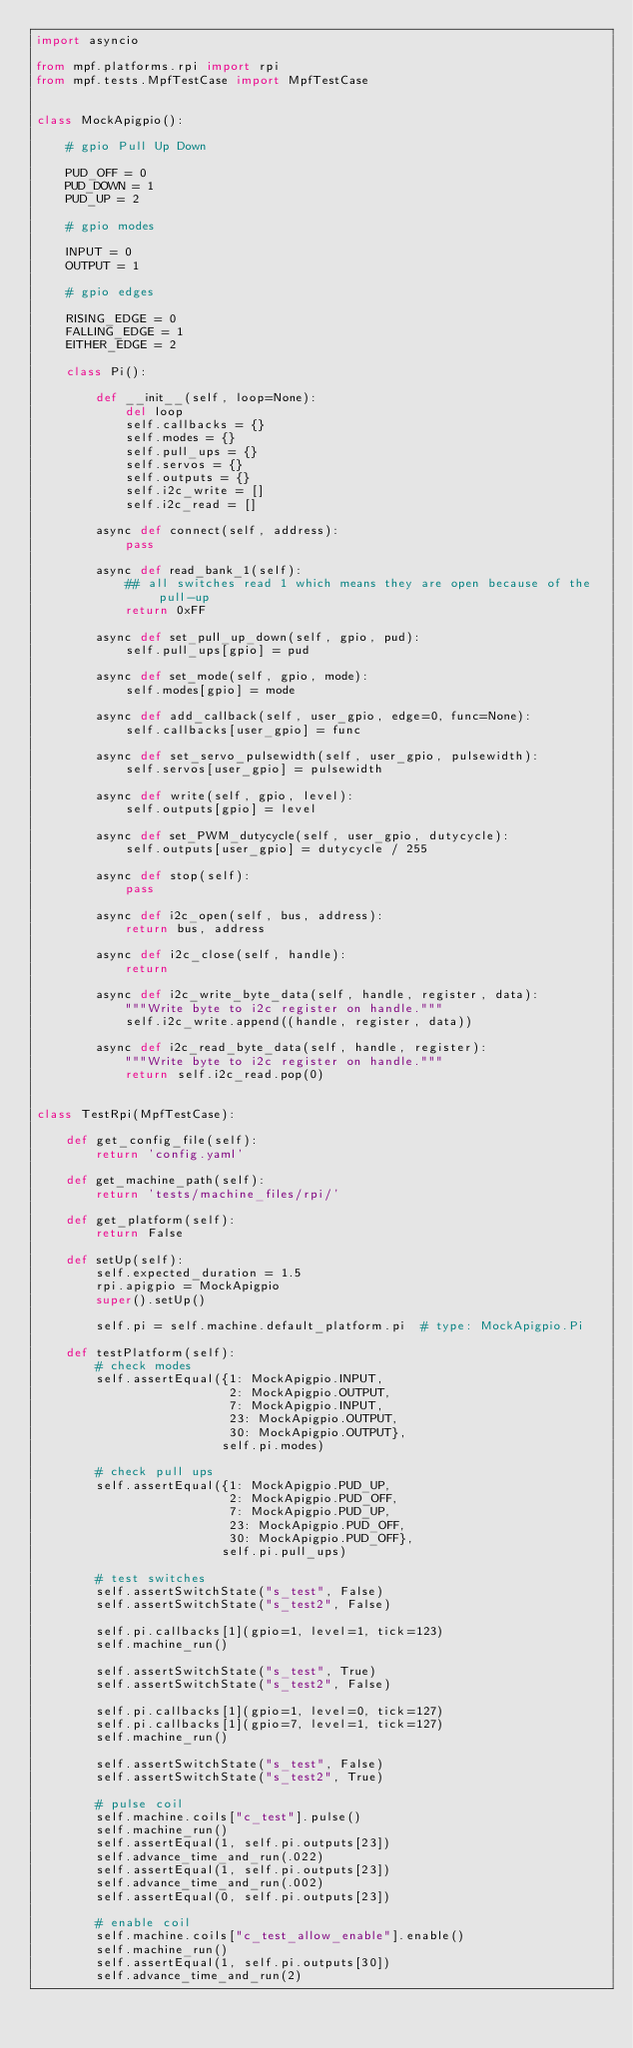Convert code to text. <code><loc_0><loc_0><loc_500><loc_500><_Python_>import asyncio

from mpf.platforms.rpi import rpi
from mpf.tests.MpfTestCase import MpfTestCase


class MockApigpio():

    # gpio Pull Up Down

    PUD_OFF = 0
    PUD_DOWN = 1
    PUD_UP = 2

    # gpio modes

    INPUT = 0
    OUTPUT = 1

    # gpio edges

    RISING_EDGE = 0
    FALLING_EDGE = 1
    EITHER_EDGE = 2

    class Pi():

        def __init__(self, loop=None):
            del loop
            self.callbacks = {}
            self.modes = {}
            self.pull_ups = {}
            self.servos = {}
            self.outputs = {}
            self.i2c_write = []
            self.i2c_read = []

        async def connect(self, address):
            pass

        async def read_bank_1(self):
            ## all switches read 1 which means they are open because of the pull-up
            return 0xFF

        async def set_pull_up_down(self, gpio, pud):
            self.pull_ups[gpio] = pud

        async def set_mode(self, gpio, mode):
            self.modes[gpio] = mode

        async def add_callback(self, user_gpio, edge=0, func=None):
            self.callbacks[user_gpio] = func

        async def set_servo_pulsewidth(self, user_gpio, pulsewidth):
            self.servos[user_gpio] = pulsewidth

        async def write(self, gpio, level):
            self.outputs[gpio] = level

        async def set_PWM_dutycycle(self, user_gpio, dutycycle):
            self.outputs[user_gpio] = dutycycle / 255

        async def stop(self):
            pass

        async def i2c_open(self, bus, address):
            return bus, address

        async def i2c_close(self, handle):
            return

        async def i2c_write_byte_data(self, handle, register, data):
            """Write byte to i2c register on handle."""
            self.i2c_write.append((handle, register, data))

        async def i2c_read_byte_data(self, handle, register):
            """Write byte to i2c register on handle."""
            return self.i2c_read.pop(0)


class TestRpi(MpfTestCase):

    def get_config_file(self):
        return 'config.yaml'

    def get_machine_path(self):
        return 'tests/machine_files/rpi/'

    def get_platform(self):
        return False

    def setUp(self):
        self.expected_duration = 1.5
        rpi.apigpio = MockApigpio
        super().setUp()

        self.pi = self.machine.default_platform.pi  # type: MockApigpio.Pi

    def testPlatform(self):
        # check modes
        self.assertEqual({1: MockApigpio.INPUT,
                          2: MockApigpio.OUTPUT,
                          7: MockApigpio.INPUT,
                          23: MockApigpio.OUTPUT,
                          30: MockApigpio.OUTPUT},
                         self.pi.modes)

        # check pull ups
        self.assertEqual({1: MockApigpio.PUD_UP,
                          2: MockApigpio.PUD_OFF,
                          7: MockApigpio.PUD_UP,
                          23: MockApigpio.PUD_OFF,
                          30: MockApigpio.PUD_OFF},
                         self.pi.pull_ups)

        # test switches
        self.assertSwitchState("s_test", False)
        self.assertSwitchState("s_test2", False)

        self.pi.callbacks[1](gpio=1, level=1, tick=123)
        self.machine_run()

        self.assertSwitchState("s_test", True)
        self.assertSwitchState("s_test2", False)

        self.pi.callbacks[1](gpio=1, level=0, tick=127)
        self.pi.callbacks[1](gpio=7, level=1, tick=127)
        self.machine_run()

        self.assertSwitchState("s_test", False)
        self.assertSwitchState("s_test2", True)

        # pulse coil
        self.machine.coils["c_test"].pulse()
        self.machine_run()
        self.assertEqual(1, self.pi.outputs[23])
        self.advance_time_and_run(.022)
        self.assertEqual(1, self.pi.outputs[23])
        self.advance_time_and_run(.002)
        self.assertEqual(0, self.pi.outputs[23])

        # enable coil
        self.machine.coils["c_test_allow_enable"].enable()
        self.machine_run()
        self.assertEqual(1, self.pi.outputs[30])
        self.advance_time_and_run(2)</code> 